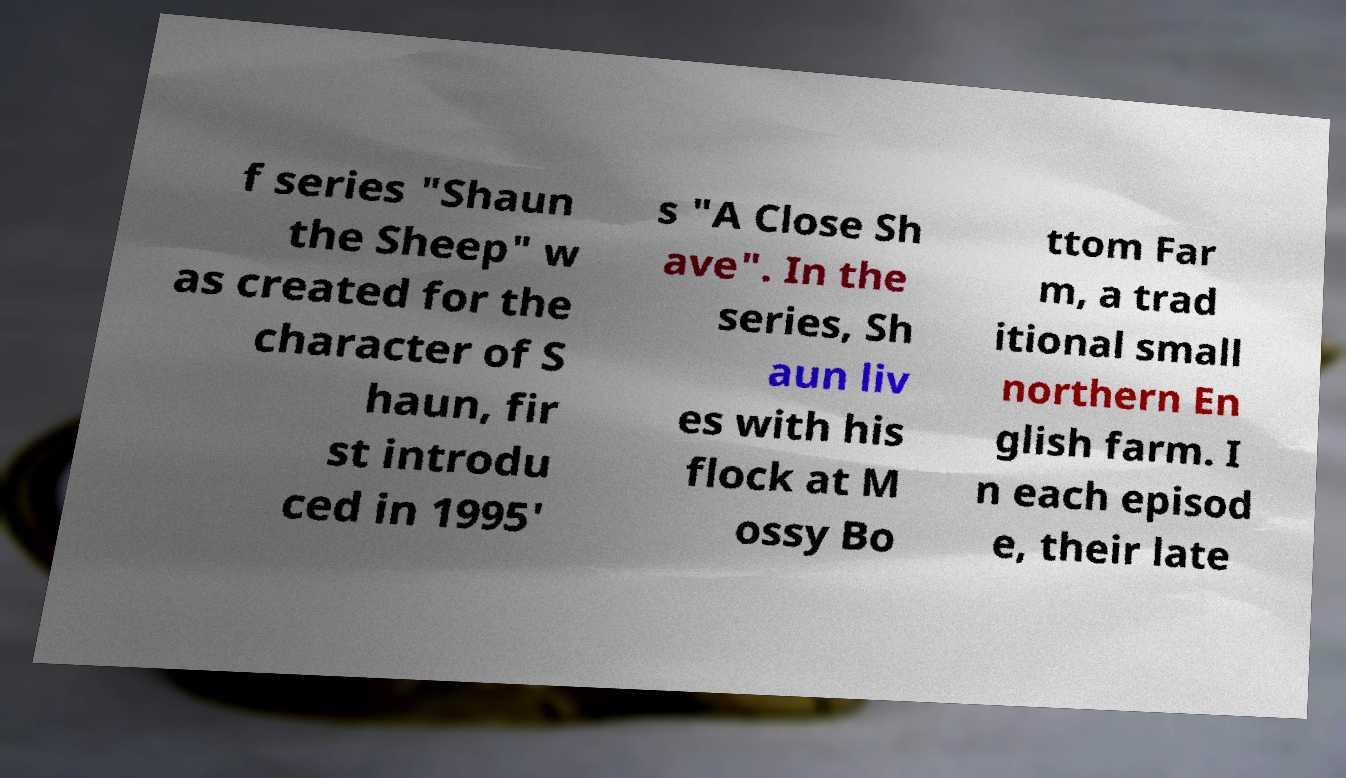Please read and relay the text visible in this image. What does it say? f series "Shaun the Sheep" w as created for the character of S haun, fir st introdu ced in 1995' s "A Close Sh ave". In the series, Sh aun liv es with his flock at M ossy Bo ttom Far m, a trad itional small northern En glish farm. I n each episod e, their late 